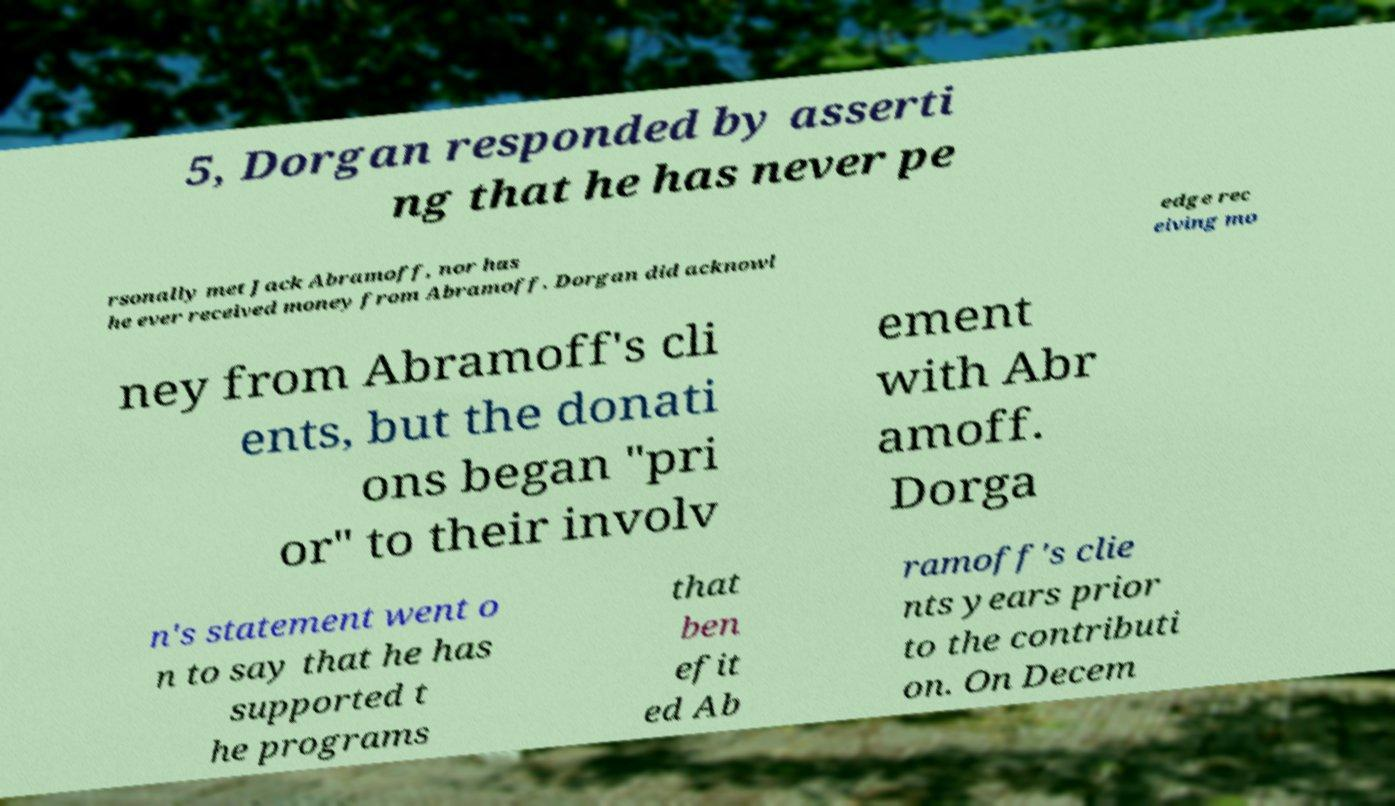Can you accurately transcribe the text from the provided image for me? 5, Dorgan responded by asserti ng that he has never pe rsonally met Jack Abramoff, nor has he ever received money from Abramoff. Dorgan did acknowl edge rec eiving mo ney from Abramoff's cli ents, but the donati ons began "pri or" to their involv ement with Abr amoff. Dorga n's statement went o n to say that he has supported t he programs that ben efit ed Ab ramoff's clie nts years prior to the contributi on. On Decem 